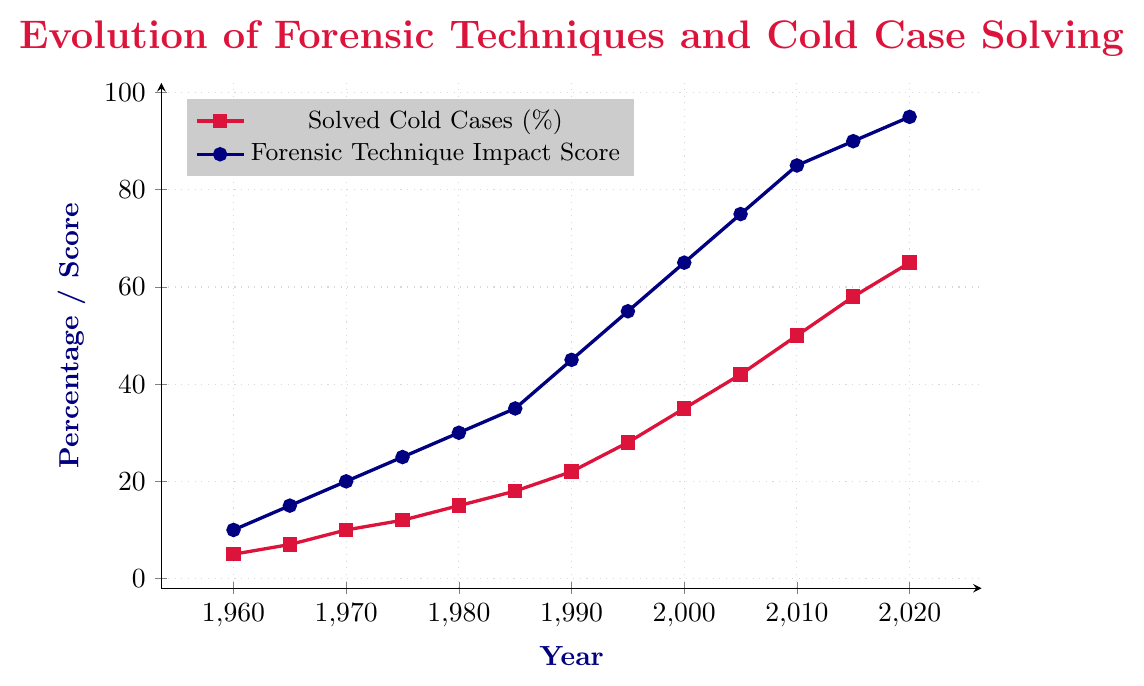What trend do you observe in the percentage of solved cold cases from 1960 to 2020? The percentage of solved cold cases shows a steady increase over the years, starting at 5% in 1960 and reaching 65% by 2020.
Answer: It increases steadily How much did the forensic technique impact score increase from 1980 to 2020? In 1980, the impact score was 30, and by 2020 it increased to 95. The difference between these values is 95 - 30.
Answer: 65 What is the visual difference between the lines representing solved cold cases and forensic technique impact score? The line for solved cold cases is drawn in crimson and marked with square points, while the line for forensic technique impact score is drawn in navy and marked with circular points.
Answer: Different colors and markers In which decade did both the solved cold cases and forensic technique impact score show the most significant increase? Compare the increments for each decade. The values increase most significantly between 2000 and 2010. For solved cold cases from 35% to 50%, and for the impact score from 65 to 85.
Answer: 2000 to 2010 By how much did the forensic technique impact score increase on average per decade from 1960 to 2020? Total change in impact score over the 60 years is 95 - 10 = 85. There are 6 decades from 1960 to 2020. So the average per decade is 85/6.
Answer: ~14.17 In which year did the solved cold cases percentage cross the 50% threshold? The solved cold cases percentage crossed 50% in the year 2010.
Answer: 2010 How much more was the forensic technique impact score in 2000 compared to 1980? In 2000, the impact score was 65, and in 1980, it was 30. The difference is 65 - 30.
Answer: 35 Which year had the highest forensic technique impact score, and what was it? The highest forensic technique impact score is 95, which was achieved in the year 2020.
Answer: 2020, 95 What is the approximate average percentage of solved cold cases from 1960 to 2020? (5+7+10+12+15+18+22+28+35+42+50+58+65) / 13 = 367 / 13
Answer: ~28.23 